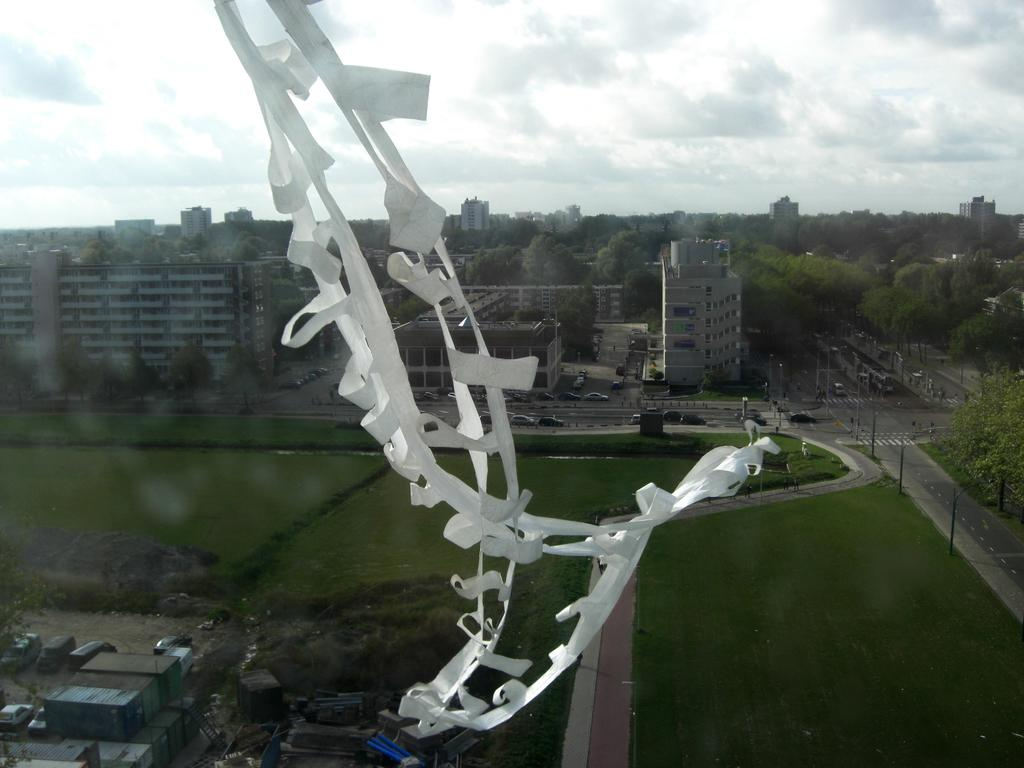What type of structures can be seen in the image? There are buildings in the image. What type of natural environment is visible in the image? There is grass and trees visible in the image. What is visible at the top of the image? The sky is visible at the top of the image. What can be seen in the sky in the image? Clouds are present in the sky. What type of vehicle is parked near the buildings in the image? There is no vehicle present in the image. What type of reasoning can be applied to understand the purpose of the buildings in the image? The image does not provide enough information to apply any specific reasoning to understand the purpose of the buildings. 